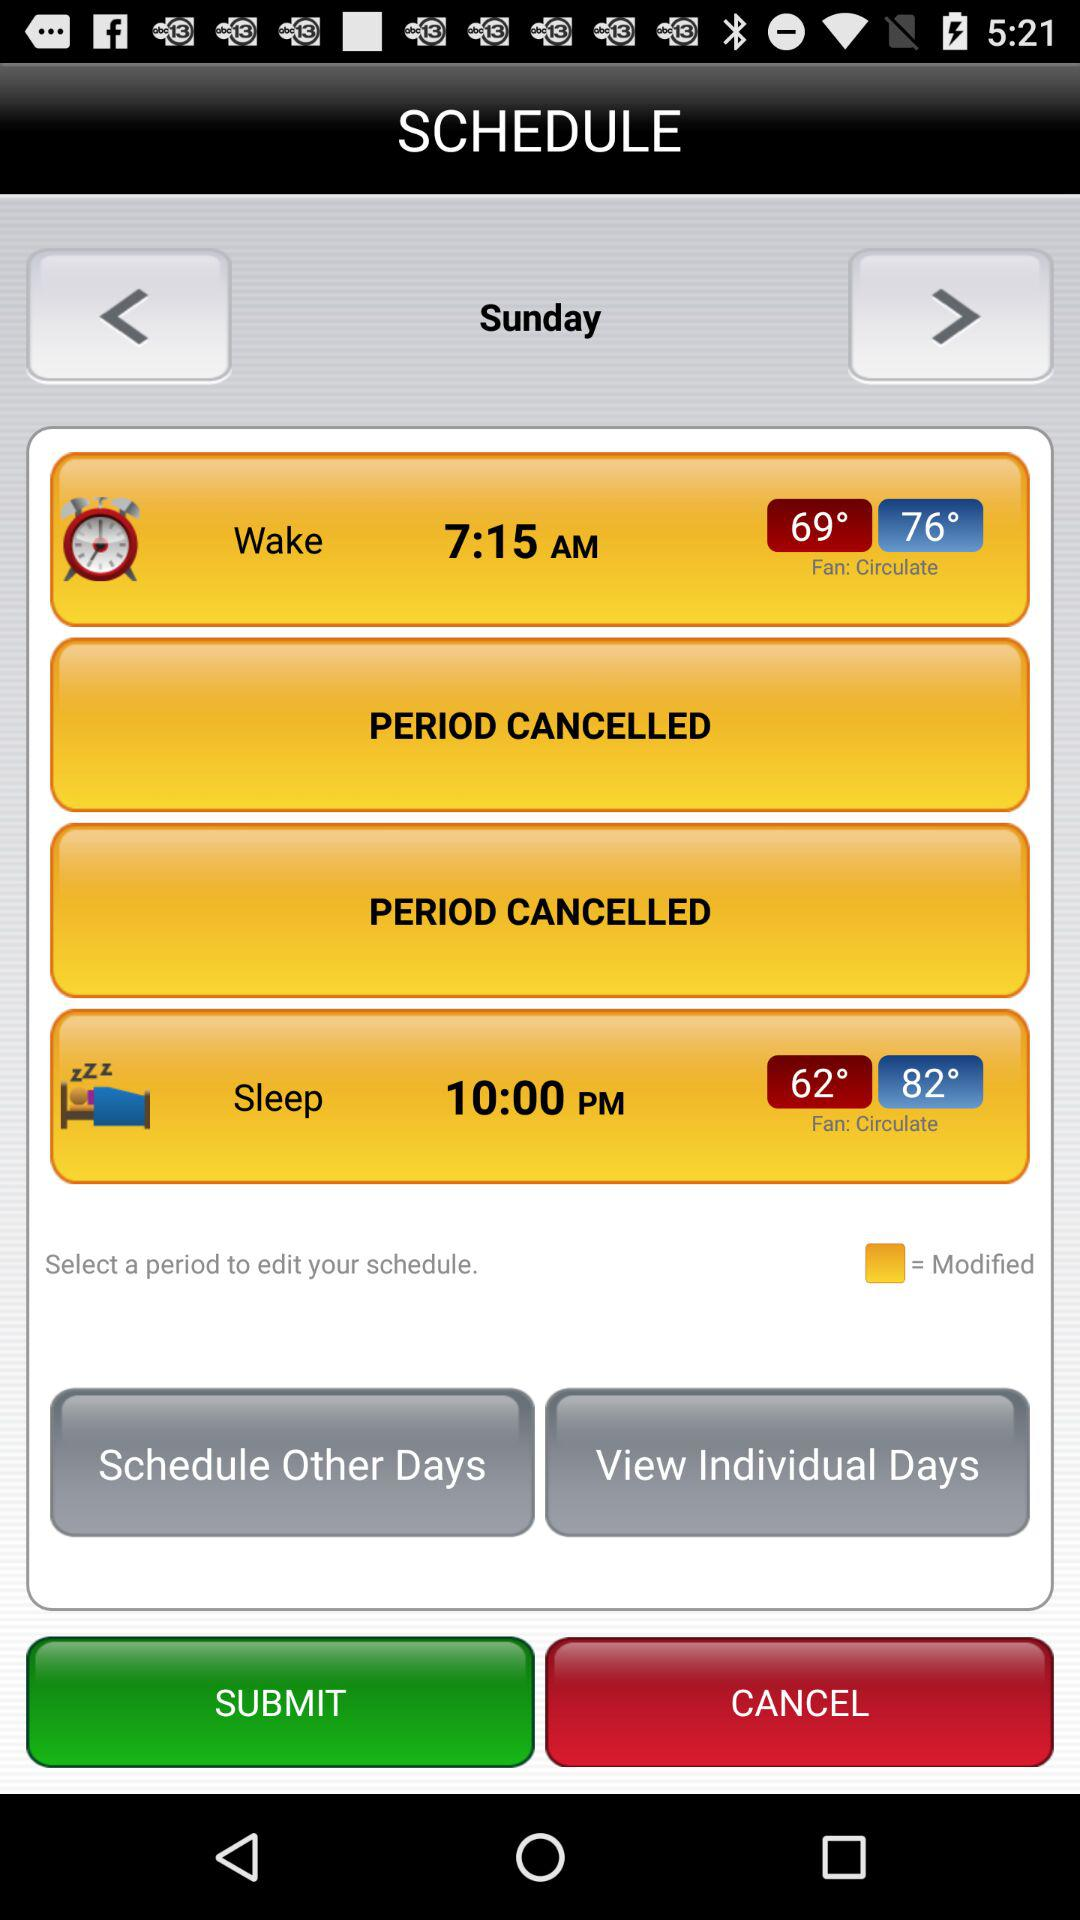How many periods have been cancelled?
Answer the question using a single word or phrase. 2 